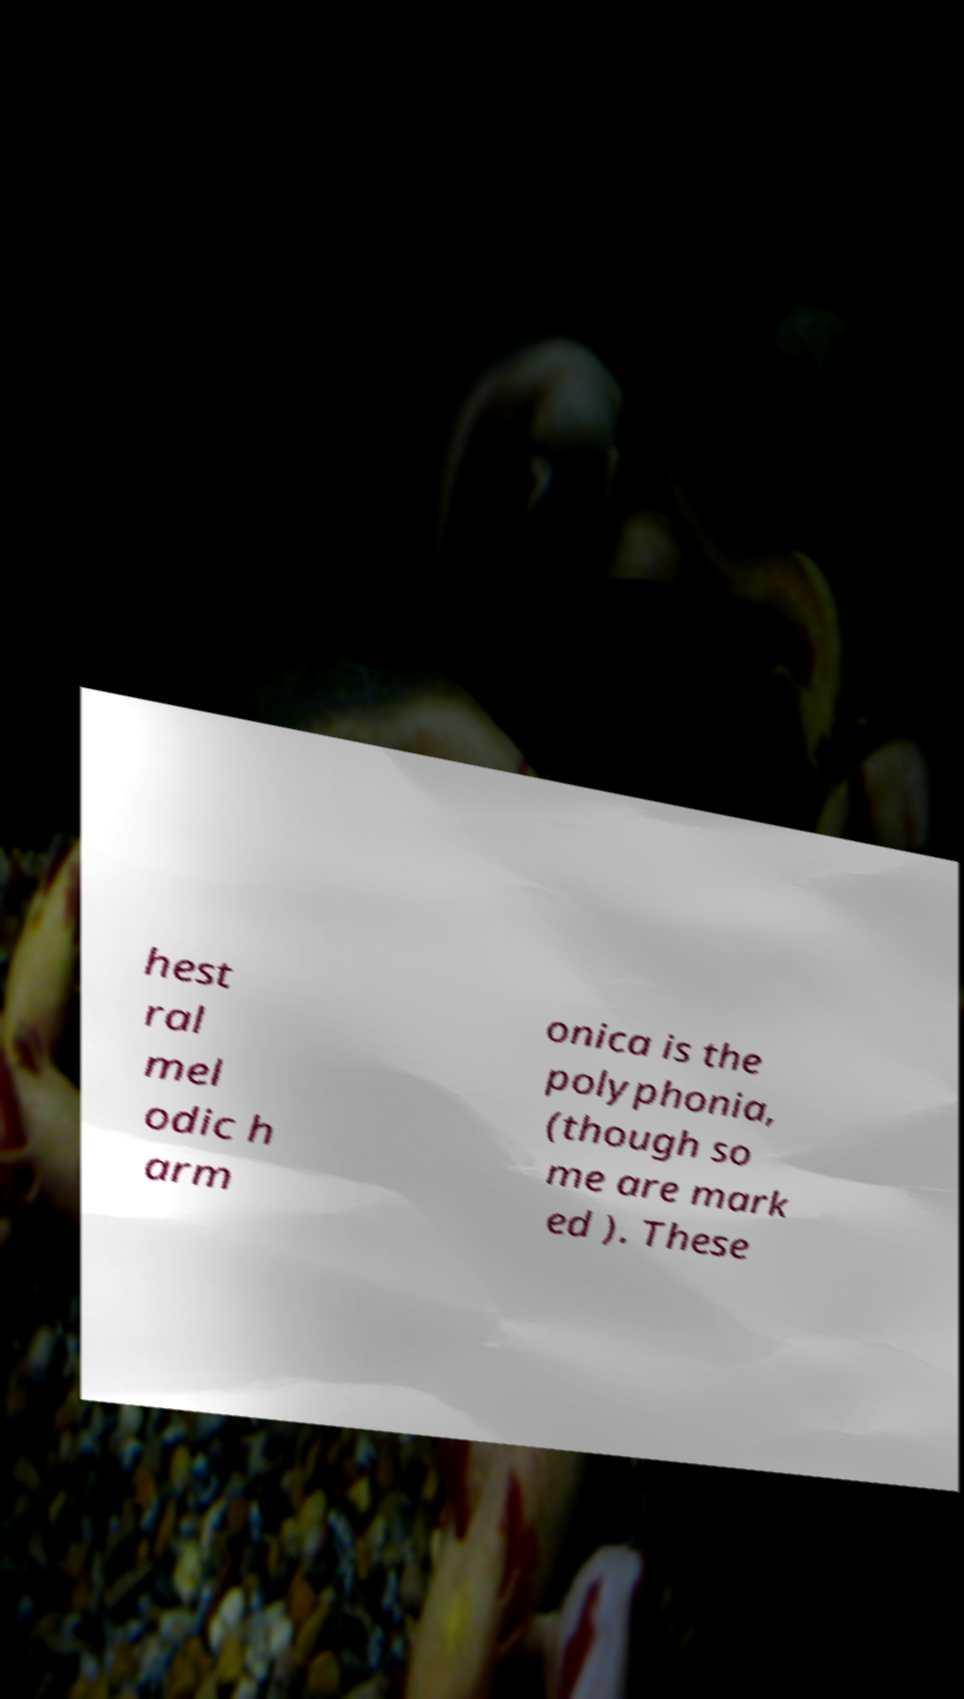What messages or text are displayed in this image? I need them in a readable, typed format. hest ral mel odic h arm onica is the polyphonia, (though so me are mark ed ). These 